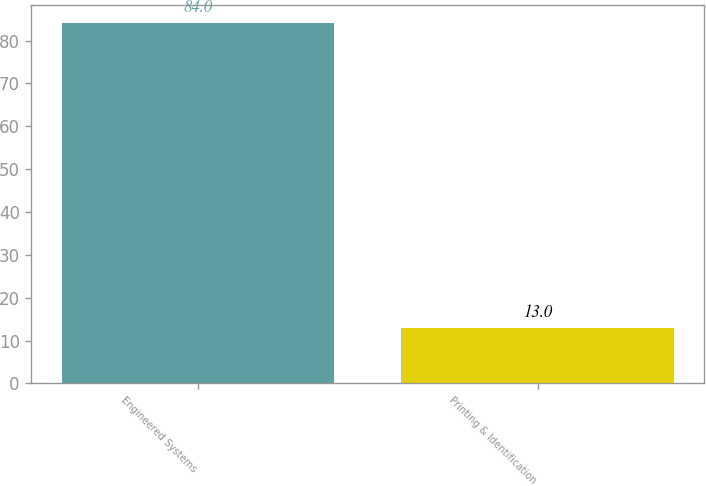Convert chart. <chart><loc_0><loc_0><loc_500><loc_500><bar_chart><fcel>Engineered Systems<fcel>Printing & Identification<nl><fcel>84<fcel>13<nl></chart> 